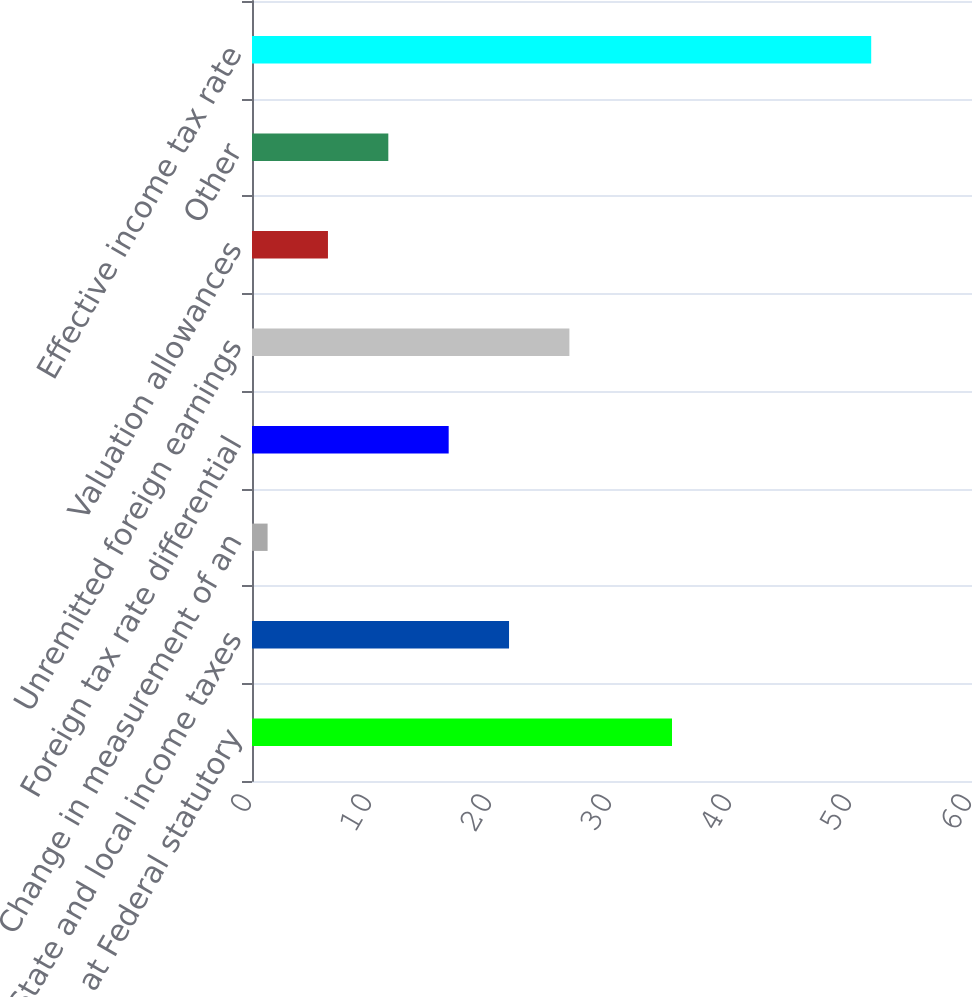Convert chart to OTSL. <chart><loc_0><loc_0><loc_500><loc_500><bar_chart><fcel>Provision at Federal statutory<fcel>State and local income taxes<fcel>Change in measurement of an<fcel>Foreign tax rate differential<fcel>Unremitted foreign earnings<fcel>Valuation allowances<fcel>Other<fcel>Effective income tax rate<nl><fcel>35<fcel>21.42<fcel>1.3<fcel>16.39<fcel>26.45<fcel>6.33<fcel>11.36<fcel>51.6<nl></chart> 